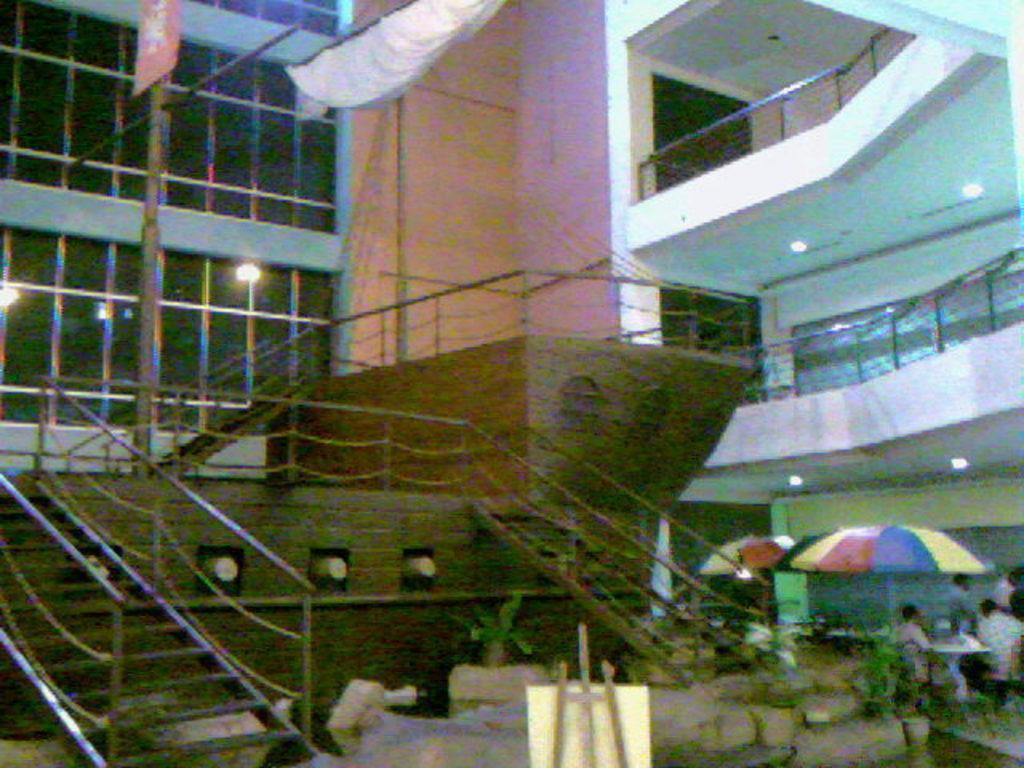Can you describe this image briefly? In this image we can see stairs, wooden boat, a board, plants, umbrellas, paper standing here, glass building and the wall in the background. 